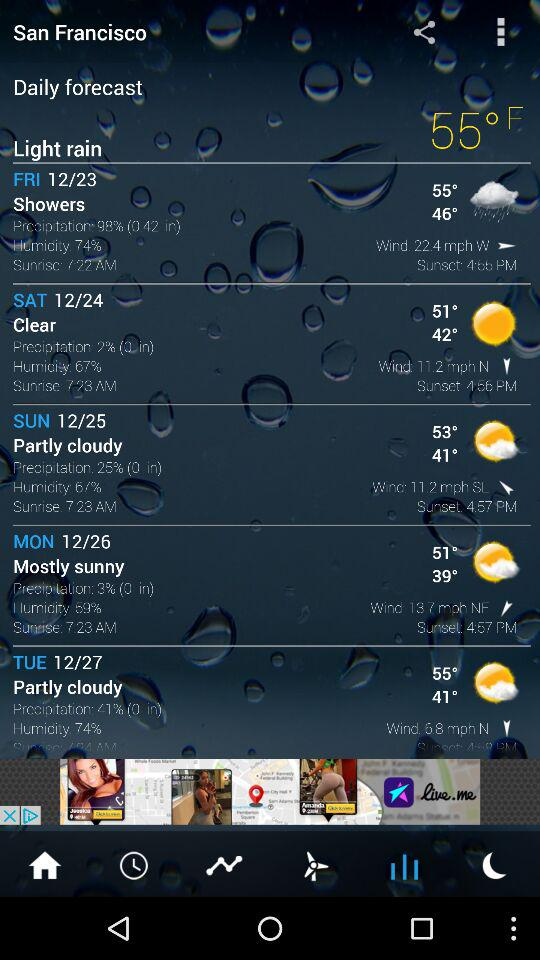How many degrees is the high temperature for Saturday?
Answer the question using a single word or phrase. 51° 